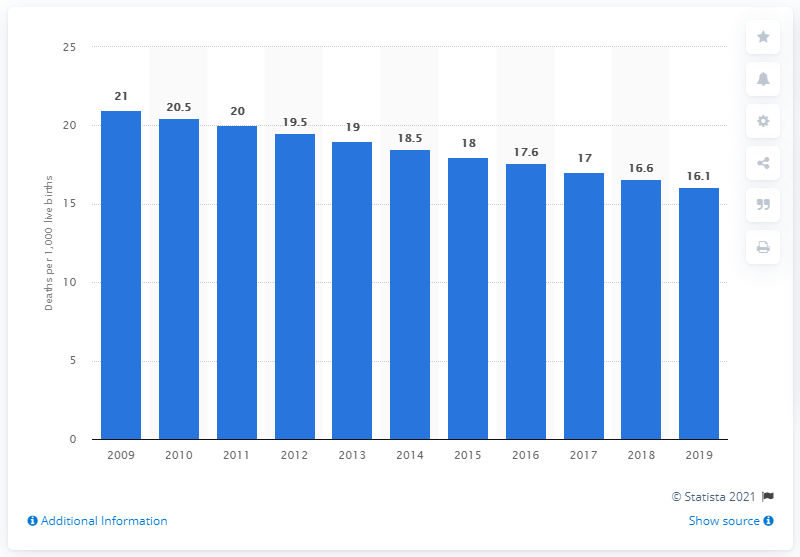Give some essential details in this illustration. In 2019, the infant mortality rate in Suriname was 16.1 deaths per 1,000 live births. 